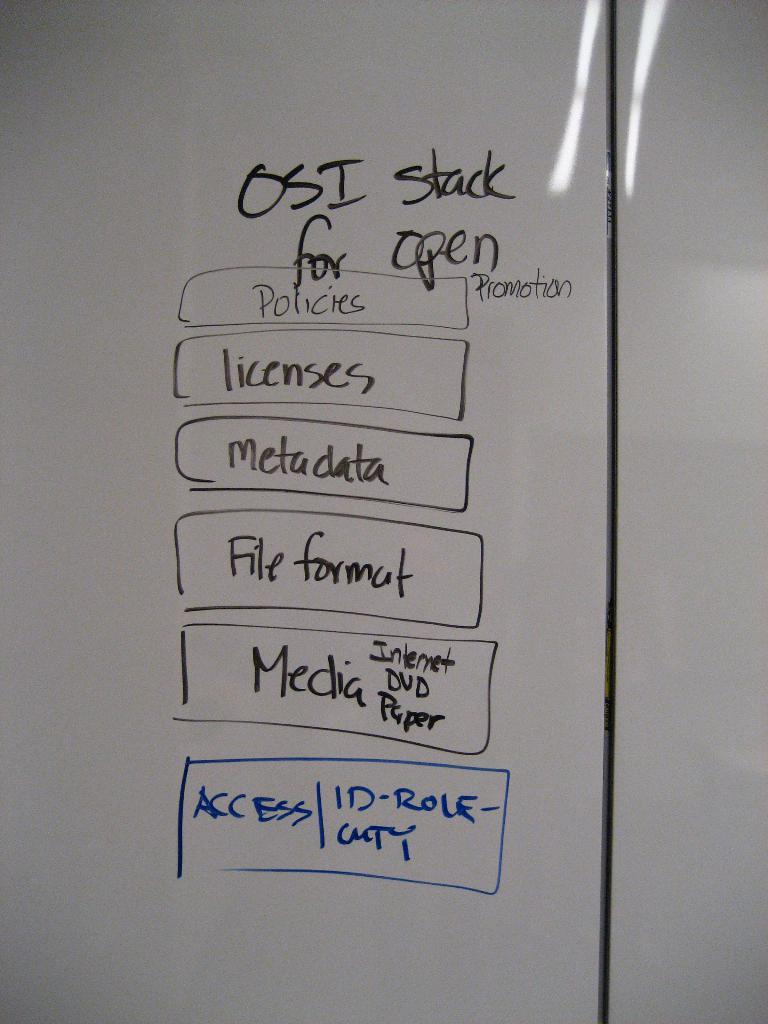<image>
Summarize the visual content of the image. A white board has words in boxes, the first one being policies. 